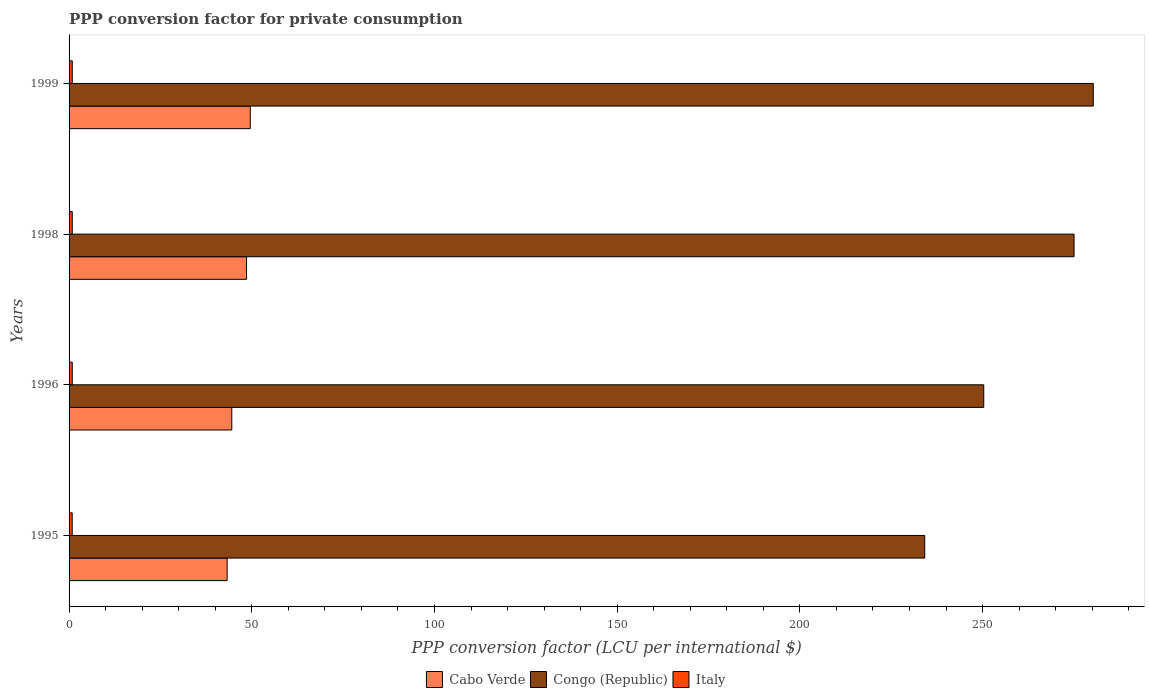What is the label of the 3rd group of bars from the top?
Provide a succinct answer. 1996. What is the PPP conversion factor for private consumption in Italy in 1996?
Offer a terse response. 0.87. Across all years, what is the maximum PPP conversion factor for private consumption in Cabo Verde?
Provide a short and direct response. 49.59. Across all years, what is the minimum PPP conversion factor for private consumption in Italy?
Offer a very short reply. 0.86. In which year was the PPP conversion factor for private consumption in Congo (Republic) maximum?
Your answer should be very brief. 1999. In which year was the PPP conversion factor for private consumption in Italy minimum?
Keep it short and to the point. 1995. What is the total PPP conversion factor for private consumption in Italy in the graph?
Your response must be concise. 3.47. What is the difference between the PPP conversion factor for private consumption in Italy in 1998 and that in 1999?
Offer a terse response. -0. What is the difference between the PPP conversion factor for private consumption in Cabo Verde in 1996 and the PPP conversion factor for private consumption in Congo (Republic) in 1995?
Keep it short and to the point. -189.63. What is the average PPP conversion factor for private consumption in Cabo Verde per year?
Provide a succinct answer. 46.49. In the year 1999, what is the difference between the PPP conversion factor for private consumption in Italy and PPP conversion factor for private consumption in Congo (Republic)?
Your answer should be very brief. -279.42. In how many years, is the PPP conversion factor for private consumption in Congo (Republic) greater than 10 LCU?
Provide a succinct answer. 4. What is the ratio of the PPP conversion factor for private consumption in Congo (Republic) in 1995 to that in 1996?
Your answer should be very brief. 0.94. Is the difference between the PPP conversion factor for private consumption in Italy in 1996 and 1998 greater than the difference between the PPP conversion factor for private consumption in Congo (Republic) in 1996 and 1998?
Provide a succinct answer. Yes. What is the difference between the highest and the second highest PPP conversion factor for private consumption in Italy?
Your response must be concise. 0. What is the difference between the highest and the lowest PPP conversion factor for private consumption in Cabo Verde?
Provide a short and direct response. 6.33. Is the sum of the PPP conversion factor for private consumption in Congo (Republic) in 1998 and 1999 greater than the maximum PPP conversion factor for private consumption in Italy across all years?
Offer a terse response. Yes. What does the 3rd bar from the top in 1995 represents?
Provide a succinct answer. Cabo Verde. What does the 2nd bar from the bottom in 1995 represents?
Your answer should be compact. Congo (Republic). Is it the case that in every year, the sum of the PPP conversion factor for private consumption in Italy and PPP conversion factor for private consumption in Cabo Verde is greater than the PPP conversion factor for private consumption in Congo (Republic)?
Provide a short and direct response. No. Are all the bars in the graph horizontal?
Give a very brief answer. Yes. Are the values on the major ticks of X-axis written in scientific E-notation?
Your answer should be compact. No. Does the graph contain any zero values?
Provide a succinct answer. No. Does the graph contain grids?
Offer a terse response. No. How are the legend labels stacked?
Offer a very short reply. Horizontal. What is the title of the graph?
Your response must be concise. PPP conversion factor for private consumption. Does "Colombia" appear as one of the legend labels in the graph?
Provide a short and direct response. No. What is the label or title of the X-axis?
Keep it short and to the point. PPP conversion factor (LCU per international $). What is the label or title of the Y-axis?
Your response must be concise. Years. What is the PPP conversion factor (LCU per international $) of Cabo Verde in 1995?
Provide a succinct answer. 43.26. What is the PPP conversion factor (LCU per international $) of Congo (Republic) in 1995?
Your answer should be very brief. 234.16. What is the PPP conversion factor (LCU per international $) in Italy in 1995?
Keep it short and to the point. 0.86. What is the PPP conversion factor (LCU per international $) in Cabo Verde in 1996?
Your response must be concise. 44.53. What is the PPP conversion factor (LCU per international $) of Congo (Republic) in 1996?
Offer a very short reply. 250.32. What is the PPP conversion factor (LCU per international $) of Italy in 1996?
Make the answer very short. 0.87. What is the PPP conversion factor (LCU per international $) in Cabo Verde in 1998?
Ensure brevity in your answer.  48.56. What is the PPP conversion factor (LCU per international $) in Congo (Republic) in 1998?
Your answer should be very brief. 275.03. What is the PPP conversion factor (LCU per international $) of Italy in 1998?
Your answer should be very brief. 0.87. What is the PPP conversion factor (LCU per international $) in Cabo Verde in 1999?
Offer a terse response. 49.59. What is the PPP conversion factor (LCU per international $) of Congo (Republic) in 1999?
Your response must be concise. 280.29. What is the PPP conversion factor (LCU per international $) in Italy in 1999?
Your answer should be very brief. 0.87. Across all years, what is the maximum PPP conversion factor (LCU per international $) of Cabo Verde?
Your answer should be very brief. 49.59. Across all years, what is the maximum PPP conversion factor (LCU per international $) in Congo (Republic)?
Make the answer very short. 280.29. Across all years, what is the maximum PPP conversion factor (LCU per international $) of Italy?
Provide a short and direct response. 0.87. Across all years, what is the minimum PPP conversion factor (LCU per international $) of Cabo Verde?
Your response must be concise. 43.26. Across all years, what is the minimum PPP conversion factor (LCU per international $) in Congo (Republic)?
Ensure brevity in your answer.  234.16. Across all years, what is the minimum PPP conversion factor (LCU per international $) of Italy?
Your answer should be very brief. 0.86. What is the total PPP conversion factor (LCU per international $) of Cabo Verde in the graph?
Your answer should be very brief. 185.95. What is the total PPP conversion factor (LCU per international $) in Congo (Republic) in the graph?
Give a very brief answer. 1039.8. What is the total PPP conversion factor (LCU per international $) in Italy in the graph?
Offer a terse response. 3.47. What is the difference between the PPP conversion factor (LCU per international $) in Cabo Verde in 1995 and that in 1996?
Your response must be concise. -1.27. What is the difference between the PPP conversion factor (LCU per international $) of Congo (Republic) in 1995 and that in 1996?
Provide a succinct answer. -16.15. What is the difference between the PPP conversion factor (LCU per international $) in Italy in 1995 and that in 1996?
Provide a succinct answer. -0.02. What is the difference between the PPP conversion factor (LCU per international $) of Cabo Verde in 1995 and that in 1998?
Give a very brief answer. -5.3. What is the difference between the PPP conversion factor (LCU per international $) in Congo (Republic) in 1995 and that in 1998?
Ensure brevity in your answer.  -40.86. What is the difference between the PPP conversion factor (LCU per international $) in Italy in 1995 and that in 1998?
Your response must be concise. -0.01. What is the difference between the PPP conversion factor (LCU per international $) in Cabo Verde in 1995 and that in 1999?
Provide a short and direct response. -6.33. What is the difference between the PPP conversion factor (LCU per international $) in Congo (Republic) in 1995 and that in 1999?
Your response must be concise. -46.13. What is the difference between the PPP conversion factor (LCU per international $) in Italy in 1995 and that in 1999?
Your response must be concise. -0.02. What is the difference between the PPP conversion factor (LCU per international $) of Cabo Verde in 1996 and that in 1998?
Provide a succinct answer. -4.03. What is the difference between the PPP conversion factor (LCU per international $) of Congo (Republic) in 1996 and that in 1998?
Offer a terse response. -24.71. What is the difference between the PPP conversion factor (LCU per international $) in Italy in 1996 and that in 1998?
Make the answer very short. 0.01. What is the difference between the PPP conversion factor (LCU per international $) in Cabo Verde in 1996 and that in 1999?
Give a very brief answer. -5.06. What is the difference between the PPP conversion factor (LCU per international $) in Congo (Republic) in 1996 and that in 1999?
Ensure brevity in your answer.  -29.97. What is the difference between the PPP conversion factor (LCU per international $) in Italy in 1996 and that in 1999?
Provide a short and direct response. 0. What is the difference between the PPP conversion factor (LCU per international $) in Cabo Verde in 1998 and that in 1999?
Ensure brevity in your answer.  -1.03. What is the difference between the PPP conversion factor (LCU per international $) of Congo (Republic) in 1998 and that in 1999?
Keep it short and to the point. -5.26. What is the difference between the PPP conversion factor (LCU per international $) in Italy in 1998 and that in 1999?
Your answer should be compact. -0. What is the difference between the PPP conversion factor (LCU per international $) of Cabo Verde in 1995 and the PPP conversion factor (LCU per international $) of Congo (Republic) in 1996?
Your answer should be compact. -207.06. What is the difference between the PPP conversion factor (LCU per international $) of Cabo Verde in 1995 and the PPP conversion factor (LCU per international $) of Italy in 1996?
Provide a short and direct response. 42.38. What is the difference between the PPP conversion factor (LCU per international $) in Congo (Republic) in 1995 and the PPP conversion factor (LCU per international $) in Italy in 1996?
Provide a succinct answer. 233.29. What is the difference between the PPP conversion factor (LCU per international $) in Cabo Verde in 1995 and the PPP conversion factor (LCU per international $) in Congo (Republic) in 1998?
Offer a very short reply. -231.77. What is the difference between the PPP conversion factor (LCU per international $) of Cabo Verde in 1995 and the PPP conversion factor (LCU per international $) of Italy in 1998?
Offer a very short reply. 42.39. What is the difference between the PPP conversion factor (LCU per international $) in Congo (Republic) in 1995 and the PPP conversion factor (LCU per international $) in Italy in 1998?
Provide a short and direct response. 233.29. What is the difference between the PPP conversion factor (LCU per international $) of Cabo Verde in 1995 and the PPP conversion factor (LCU per international $) of Congo (Republic) in 1999?
Provide a succinct answer. -237.03. What is the difference between the PPP conversion factor (LCU per international $) of Cabo Verde in 1995 and the PPP conversion factor (LCU per international $) of Italy in 1999?
Offer a terse response. 42.39. What is the difference between the PPP conversion factor (LCU per international $) in Congo (Republic) in 1995 and the PPP conversion factor (LCU per international $) in Italy in 1999?
Make the answer very short. 233.29. What is the difference between the PPP conversion factor (LCU per international $) in Cabo Verde in 1996 and the PPP conversion factor (LCU per international $) in Congo (Republic) in 1998?
Give a very brief answer. -230.5. What is the difference between the PPP conversion factor (LCU per international $) in Cabo Verde in 1996 and the PPP conversion factor (LCU per international $) in Italy in 1998?
Offer a terse response. 43.66. What is the difference between the PPP conversion factor (LCU per international $) of Congo (Republic) in 1996 and the PPP conversion factor (LCU per international $) of Italy in 1998?
Offer a terse response. 249.45. What is the difference between the PPP conversion factor (LCU per international $) of Cabo Verde in 1996 and the PPP conversion factor (LCU per international $) of Congo (Republic) in 1999?
Offer a very short reply. -235.76. What is the difference between the PPP conversion factor (LCU per international $) of Cabo Verde in 1996 and the PPP conversion factor (LCU per international $) of Italy in 1999?
Offer a very short reply. 43.66. What is the difference between the PPP conversion factor (LCU per international $) in Congo (Republic) in 1996 and the PPP conversion factor (LCU per international $) in Italy in 1999?
Your answer should be very brief. 249.44. What is the difference between the PPP conversion factor (LCU per international $) in Cabo Verde in 1998 and the PPP conversion factor (LCU per international $) in Congo (Republic) in 1999?
Keep it short and to the point. -231.73. What is the difference between the PPP conversion factor (LCU per international $) of Cabo Verde in 1998 and the PPP conversion factor (LCU per international $) of Italy in 1999?
Ensure brevity in your answer.  47.69. What is the difference between the PPP conversion factor (LCU per international $) of Congo (Republic) in 1998 and the PPP conversion factor (LCU per international $) of Italy in 1999?
Offer a terse response. 274.16. What is the average PPP conversion factor (LCU per international $) of Cabo Verde per year?
Ensure brevity in your answer.  46.49. What is the average PPP conversion factor (LCU per international $) in Congo (Republic) per year?
Offer a terse response. 259.95. What is the average PPP conversion factor (LCU per international $) of Italy per year?
Keep it short and to the point. 0.87. In the year 1995, what is the difference between the PPP conversion factor (LCU per international $) of Cabo Verde and PPP conversion factor (LCU per international $) of Congo (Republic)?
Give a very brief answer. -190.91. In the year 1995, what is the difference between the PPP conversion factor (LCU per international $) of Cabo Verde and PPP conversion factor (LCU per international $) of Italy?
Provide a succinct answer. 42.4. In the year 1995, what is the difference between the PPP conversion factor (LCU per international $) of Congo (Republic) and PPP conversion factor (LCU per international $) of Italy?
Offer a very short reply. 233.31. In the year 1996, what is the difference between the PPP conversion factor (LCU per international $) in Cabo Verde and PPP conversion factor (LCU per international $) in Congo (Republic)?
Make the answer very short. -205.78. In the year 1996, what is the difference between the PPP conversion factor (LCU per international $) in Cabo Verde and PPP conversion factor (LCU per international $) in Italy?
Offer a very short reply. 43.66. In the year 1996, what is the difference between the PPP conversion factor (LCU per international $) in Congo (Republic) and PPP conversion factor (LCU per international $) in Italy?
Provide a succinct answer. 249.44. In the year 1998, what is the difference between the PPP conversion factor (LCU per international $) of Cabo Verde and PPP conversion factor (LCU per international $) of Congo (Republic)?
Offer a very short reply. -226.47. In the year 1998, what is the difference between the PPP conversion factor (LCU per international $) of Cabo Verde and PPP conversion factor (LCU per international $) of Italy?
Offer a very short reply. 47.69. In the year 1998, what is the difference between the PPP conversion factor (LCU per international $) of Congo (Republic) and PPP conversion factor (LCU per international $) of Italy?
Make the answer very short. 274.16. In the year 1999, what is the difference between the PPP conversion factor (LCU per international $) in Cabo Verde and PPP conversion factor (LCU per international $) in Congo (Republic)?
Give a very brief answer. -230.7. In the year 1999, what is the difference between the PPP conversion factor (LCU per international $) in Cabo Verde and PPP conversion factor (LCU per international $) in Italy?
Provide a short and direct response. 48.72. In the year 1999, what is the difference between the PPP conversion factor (LCU per international $) in Congo (Republic) and PPP conversion factor (LCU per international $) in Italy?
Your response must be concise. 279.42. What is the ratio of the PPP conversion factor (LCU per international $) of Cabo Verde in 1995 to that in 1996?
Your response must be concise. 0.97. What is the ratio of the PPP conversion factor (LCU per international $) in Congo (Republic) in 1995 to that in 1996?
Ensure brevity in your answer.  0.94. What is the ratio of the PPP conversion factor (LCU per international $) in Italy in 1995 to that in 1996?
Offer a terse response. 0.98. What is the ratio of the PPP conversion factor (LCU per international $) in Cabo Verde in 1995 to that in 1998?
Offer a very short reply. 0.89. What is the ratio of the PPP conversion factor (LCU per international $) of Congo (Republic) in 1995 to that in 1998?
Give a very brief answer. 0.85. What is the ratio of the PPP conversion factor (LCU per international $) of Italy in 1995 to that in 1998?
Provide a short and direct response. 0.98. What is the ratio of the PPP conversion factor (LCU per international $) of Cabo Verde in 1995 to that in 1999?
Your answer should be compact. 0.87. What is the ratio of the PPP conversion factor (LCU per international $) in Congo (Republic) in 1995 to that in 1999?
Ensure brevity in your answer.  0.84. What is the ratio of the PPP conversion factor (LCU per international $) in Italy in 1995 to that in 1999?
Ensure brevity in your answer.  0.98. What is the ratio of the PPP conversion factor (LCU per international $) of Cabo Verde in 1996 to that in 1998?
Make the answer very short. 0.92. What is the ratio of the PPP conversion factor (LCU per international $) of Congo (Republic) in 1996 to that in 1998?
Ensure brevity in your answer.  0.91. What is the ratio of the PPP conversion factor (LCU per international $) of Italy in 1996 to that in 1998?
Keep it short and to the point. 1.01. What is the ratio of the PPP conversion factor (LCU per international $) of Cabo Verde in 1996 to that in 1999?
Provide a succinct answer. 0.9. What is the ratio of the PPP conversion factor (LCU per international $) in Congo (Republic) in 1996 to that in 1999?
Make the answer very short. 0.89. What is the ratio of the PPP conversion factor (LCU per international $) of Italy in 1996 to that in 1999?
Your response must be concise. 1. What is the ratio of the PPP conversion factor (LCU per international $) in Cabo Verde in 1998 to that in 1999?
Provide a short and direct response. 0.98. What is the ratio of the PPP conversion factor (LCU per international $) of Congo (Republic) in 1998 to that in 1999?
Your response must be concise. 0.98. What is the difference between the highest and the second highest PPP conversion factor (LCU per international $) of Cabo Verde?
Keep it short and to the point. 1.03. What is the difference between the highest and the second highest PPP conversion factor (LCU per international $) in Congo (Republic)?
Your answer should be very brief. 5.26. What is the difference between the highest and the second highest PPP conversion factor (LCU per international $) in Italy?
Your answer should be very brief. 0. What is the difference between the highest and the lowest PPP conversion factor (LCU per international $) in Cabo Verde?
Offer a very short reply. 6.33. What is the difference between the highest and the lowest PPP conversion factor (LCU per international $) in Congo (Republic)?
Your answer should be very brief. 46.13. What is the difference between the highest and the lowest PPP conversion factor (LCU per international $) in Italy?
Your answer should be very brief. 0.02. 